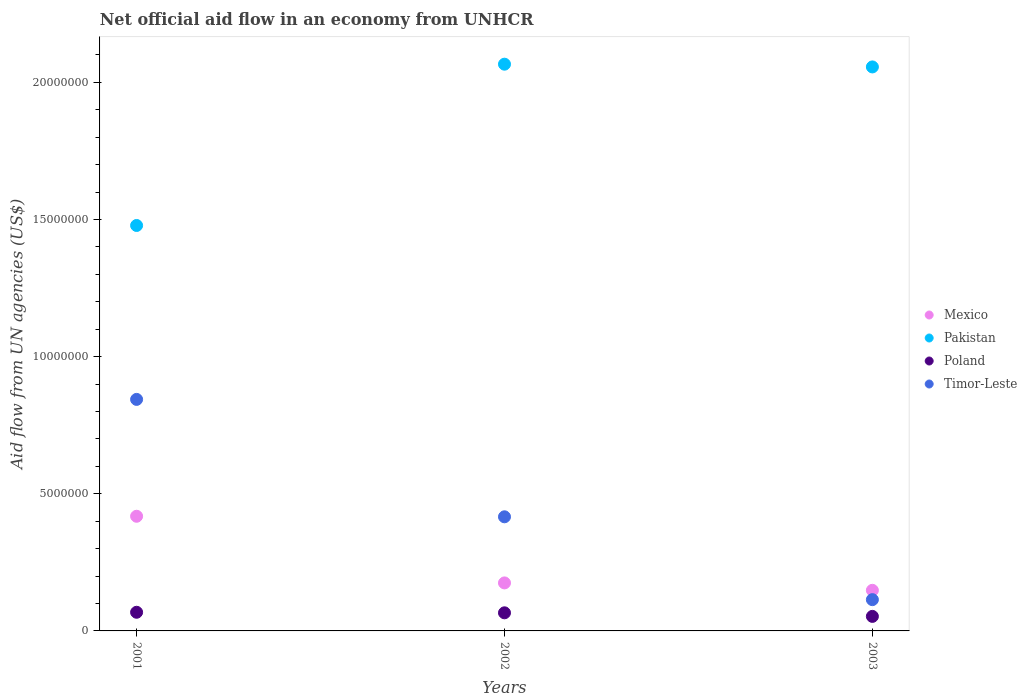Is the number of dotlines equal to the number of legend labels?
Provide a succinct answer. Yes. What is the net official aid flow in Poland in 2001?
Ensure brevity in your answer.  6.80e+05. Across all years, what is the maximum net official aid flow in Poland?
Make the answer very short. 6.80e+05. Across all years, what is the minimum net official aid flow in Mexico?
Offer a terse response. 1.48e+06. In which year was the net official aid flow in Timor-Leste maximum?
Make the answer very short. 2001. In which year was the net official aid flow in Timor-Leste minimum?
Your answer should be very brief. 2003. What is the total net official aid flow in Timor-Leste in the graph?
Ensure brevity in your answer.  1.37e+07. What is the difference between the net official aid flow in Pakistan in 2002 and that in 2003?
Provide a short and direct response. 1.00e+05. What is the difference between the net official aid flow in Pakistan in 2002 and the net official aid flow in Poland in 2003?
Keep it short and to the point. 2.01e+07. What is the average net official aid flow in Poland per year?
Keep it short and to the point. 6.23e+05. In the year 2002, what is the difference between the net official aid flow in Pakistan and net official aid flow in Poland?
Offer a very short reply. 2.00e+07. In how many years, is the net official aid flow in Pakistan greater than 2000000 US$?
Provide a succinct answer. 3. What is the ratio of the net official aid flow in Poland in 2001 to that in 2002?
Provide a short and direct response. 1.03. Is the net official aid flow in Poland in 2001 less than that in 2002?
Offer a terse response. No. What is the difference between the highest and the lowest net official aid flow in Mexico?
Keep it short and to the point. 2.70e+06. Is the sum of the net official aid flow in Mexico in 2002 and 2003 greater than the maximum net official aid flow in Poland across all years?
Make the answer very short. Yes. Is it the case that in every year, the sum of the net official aid flow in Mexico and net official aid flow in Poland  is greater than the net official aid flow in Pakistan?
Ensure brevity in your answer.  No. Does the net official aid flow in Pakistan monotonically increase over the years?
Provide a short and direct response. No. Does the graph contain grids?
Provide a succinct answer. No. Where does the legend appear in the graph?
Your answer should be very brief. Center right. How are the legend labels stacked?
Provide a succinct answer. Vertical. What is the title of the graph?
Offer a terse response. Net official aid flow in an economy from UNHCR. Does "Heavily indebted poor countries" appear as one of the legend labels in the graph?
Your answer should be compact. No. What is the label or title of the Y-axis?
Offer a terse response. Aid flow from UN agencies (US$). What is the Aid flow from UN agencies (US$) in Mexico in 2001?
Your response must be concise. 4.18e+06. What is the Aid flow from UN agencies (US$) in Pakistan in 2001?
Keep it short and to the point. 1.48e+07. What is the Aid flow from UN agencies (US$) in Poland in 2001?
Ensure brevity in your answer.  6.80e+05. What is the Aid flow from UN agencies (US$) in Timor-Leste in 2001?
Your answer should be compact. 8.44e+06. What is the Aid flow from UN agencies (US$) of Mexico in 2002?
Your answer should be compact. 1.75e+06. What is the Aid flow from UN agencies (US$) of Pakistan in 2002?
Your answer should be very brief. 2.07e+07. What is the Aid flow from UN agencies (US$) in Timor-Leste in 2002?
Offer a very short reply. 4.16e+06. What is the Aid flow from UN agencies (US$) in Mexico in 2003?
Your answer should be very brief. 1.48e+06. What is the Aid flow from UN agencies (US$) of Pakistan in 2003?
Ensure brevity in your answer.  2.06e+07. What is the Aid flow from UN agencies (US$) of Poland in 2003?
Offer a terse response. 5.30e+05. What is the Aid flow from UN agencies (US$) of Timor-Leste in 2003?
Your answer should be compact. 1.14e+06. Across all years, what is the maximum Aid flow from UN agencies (US$) in Mexico?
Make the answer very short. 4.18e+06. Across all years, what is the maximum Aid flow from UN agencies (US$) in Pakistan?
Offer a terse response. 2.07e+07. Across all years, what is the maximum Aid flow from UN agencies (US$) of Poland?
Offer a terse response. 6.80e+05. Across all years, what is the maximum Aid flow from UN agencies (US$) of Timor-Leste?
Provide a succinct answer. 8.44e+06. Across all years, what is the minimum Aid flow from UN agencies (US$) in Mexico?
Ensure brevity in your answer.  1.48e+06. Across all years, what is the minimum Aid flow from UN agencies (US$) of Pakistan?
Make the answer very short. 1.48e+07. Across all years, what is the minimum Aid flow from UN agencies (US$) of Poland?
Make the answer very short. 5.30e+05. Across all years, what is the minimum Aid flow from UN agencies (US$) of Timor-Leste?
Offer a very short reply. 1.14e+06. What is the total Aid flow from UN agencies (US$) in Mexico in the graph?
Offer a very short reply. 7.41e+06. What is the total Aid flow from UN agencies (US$) of Pakistan in the graph?
Your answer should be very brief. 5.60e+07. What is the total Aid flow from UN agencies (US$) of Poland in the graph?
Ensure brevity in your answer.  1.87e+06. What is the total Aid flow from UN agencies (US$) in Timor-Leste in the graph?
Give a very brief answer. 1.37e+07. What is the difference between the Aid flow from UN agencies (US$) of Mexico in 2001 and that in 2002?
Offer a terse response. 2.43e+06. What is the difference between the Aid flow from UN agencies (US$) in Pakistan in 2001 and that in 2002?
Offer a terse response. -5.88e+06. What is the difference between the Aid flow from UN agencies (US$) of Poland in 2001 and that in 2002?
Keep it short and to the point. 2.00e+04. What is the difference between the Aid flow from UN agencies (US$) in Timor-Leste in 2001 and that in 2002?
Make the answer very short. 4.28e+06. What is the difference between the Aid flow from UN agencies (US$) of Mexico in 2001 and that in 2003?
Provide a succinct answer. 2.70e+06. What is the difference between the Aid flow from UN agencies (US$) in Pakistan in 2001 and that in 2003?
Ensure brevity in your answer.  -5.78e+06. What is the difference between the Aid flow from UN agencies (US$) in Poland in 2001 and that in 2003?
Make the answer very short. 1.50e+05. What is the difference between the Aid flow from UN agencies (US$) of Timor-Leste in 2001 and that in 2003?
Provide a succinct answer. 7.30e+06. What is the difference between the Aid flow from UN agencies (US$) in Poland in 2002 and that in 2003?
Provide a short and direct response. 1.30e+05. What is the difference between the Aid flow from UN agencies (US$) of Timor-Leste in 2002 and that in 2003?
Make the answer very short. 3.02e+06. What is the difference between the Aid flow from UN agencies (US$) of Mexico in 2001 and the Aid flow from UN agencies (US$) of Pakistan in 2002?
Make the answer very short. -1.65e+07. What is the difference between the Aid flow from UN agencies (US$) in Mexico in 2001 and the Aid flow from UN agencies (US$) in Poland in 2002?
Offer a very short reply. 3.52e+06. What is the difference between the Aid flow from UN agencies (US$) of Mexico in 2001 and the Aid flow from UN agencies (US$) of Timor-Leste in 2002?
Your response must be concise. 2.00e+04. What is the difference between the Aid flow from UN agencies (US$) in Pakistan in 2001 and the Aid flow from UN agencies (US$) in Poland in 2002?
Provide a short and direct response. 1.41e+07. What is the difference between the Aid flow from UN agencies (US$) in Pakistan in 2001 and the Aid flow from UN agencies (US$) in Timor-Leste in 2002?
Provide a short and direct response. 1.06e+07. What is the difference between the Aid flow from UN agencies (US$) in Poland in 2001 and the Aid flow from UN agencies (US$) in Timor-Leste in 2002?
Your answer should be compact. -3.48e+06. What is the difference between the Aid flow from UN agencies (US$) in Mexico in 2001 and the Aid flow from UN agencies (US$) in Pakistan in 2003?
Your answer should be very brief. -1.64e+07. What is the difference between the Aid flow from UN agencies (US$) of Mexico in 2001 and the Aid flow from UN agencies (US$) of Poland in 2003?
Provide a short and direct response. 3.65e+06. What is the difference between the Aid flow from UN agencies (US$) in Mexico in 2001 and the Aid flow from UN agencies (US$) in Timor-Leste in 2003?
Your answer should be compact. 3.04e+06. What is the difference between the Aid flow from UN agencies (US$) in Pakistan in 2001 and the Aid flow from UN agencies (US$) in Poland in 2003?
Your answer should be compact. 1.42e+07. What is the difference between the Aid flow from UN agencies (US$) of Pakistan in 2001 and the Aid flow from UN agencies (US$) of Timor-Leste in 2003?
Ensure brevity in your answer.  1.36e+07. What is the difference between the Aid flow from UN agencies (US$) of Poland in 2001 and the Aid flow from UN agencies (US$) of Timor-Leste in 2003?
Ensure brevity in your answer.  -4.60e+05. What is the difference between the Aid flow from UN agencies (US$) of Mexico in 2002 and the Aid flow from UN agencies (US$) of Pakistan in 2003?
Your response must be concise. -1.88e+07. What is the difference between the Aid flow from UN agencies (US$) in Mexico in 2002 and the Aid flow from UN agencies (US$) in Poland in 2003?
Your answer should be compact. 1.22e+06. What is the difference between the Aid flow from UN agencies (US$) of Pakistan in 2002 and the Aid flow from UN agencies (US$) of Poland in 2003?
Your response must be concise. 2.01e+07. What is the difference between the Aid flow from UN agencies (US$) of Pakistan in 2002 and the Aid flow from UN agencies (US$) of Timor-Leste in 2003?
Provide a succinct answer. 1.95e+07. What is the difference between the Aid flow from UN agencies (US$) in Poland in 2002 and the Aid flow from UN agencies (US$) in Timor-Leste in 2003?
Ensure brevity in your answer.  -4.80e+05. What is the average Aid flow from UN agencies (US$) of Mexico per year?
Your answer should be compact. 2.47e+06. What is the average Aid flow from UN agencies (US$) of Pakistan per year?
Make the answer very short. 1.87e+07. What is the average Aid flow from UN agencies (US$) of Poland per year?
Provide a short and direct response. 6.23e+05. What is the average Aid flow from UN agencies (US$) of Timor-Leste per year?
Your answer should be very brief. 4.58e+06. In the year 2001, what is the difference between the Aid flow from UN agencies (US$) of Mexico and Aid flow from UN agencies (US$) of Pakistan?
Offer a very short reply. -1.06e+07. In the year 2001, what is the difference between the Aid flow from UN agencies (US$) of Mexico and Aid flow from UN agencies (US$) of Poland?
Give a very brief answer. 3.50e+06. In the year 2001, what is the difference between the Aid flow from UN agencies (US$) in Mexico and Aid flow from UN agencies (US$) in Timor-Leste?
Your response must be concise. -4.26e+06. In the year 2001, what is the difference between the Aid flow from UN agencies (US$) in Pakistan and Aid flow from UN agencies (US$) in Poland?
Provide a short and direct response. 1.41e+07. In the year 2001, what is the difference between the Aid flow from UN agencies (US$) of Pakistan and Aid flow from UN agencies (US$) of Timor-Leste?
Your answer should be compact. 6.34e+06. In the year 2001, what is the difference between the Aid flow from UN agencies (US$) in Poland and Aid flow from UN agencies (US$) in Timor-Leste?
Provide a succinct answer. -7.76e+06. In the year 2002, what is the difference between the Aid flow from UN agencies (US$) in Mexico and Aid flow from UN agencies (US$) in Pakistan?
Your response must be concise. -1.89e+07. In the year 2002, what is the difference between the Aid flow from UN agencies (US$) of Mexico and Aid flow from UN agencies (US$) of Poland?
Your answer should be very brief. 1.09e+06. In the year 2002, what is the difference between the Aid flow from UN agencies (US$) in Mexico and Aid flow from UN agencies (US$) in Timor-Leste?
Your response must be concise. -2.41e+06. In the year 2002, what is the difference between the Aid flow from UN agencies (US$) in Pakistan and Aid flow from UN agencies (US$) in Timor-Leste?
Offer a very short reply. 1.65e+07. In the year 2002, what is the difference between the Aid flow from UN agencies (US$) of Poland and Aid flow from UN agencies (US$) of Timor-Leste?
Keep it short and to the point. -3.50e+06. In the year 2003, what is the difference between the Aid flow from UN agencies (US$) in Mexico and Aid flow from UN agencies (US$) in Pakistan?
Keep it short and to the point. -1.91e+07. In the year 2003, what is the difference between the Aid flow from UN agencies (US$) of Mexico and Aid flow from UN agencies (US$) of Poland?
Your response must be concise. 9.50e+05. In the year 2003, what is the difference between the Aid flow from UN agencies (US$) in Pakistan and Aid flow from UN agencies (US$) in Poland?
Make the answer very short. 2.00e+07. In the year 2003, what is the difference between the Aid flow from UN agencies (US$) of Pakistan and Aid flow from UN agencies (US$) of Timor-Leste?
Your response must be concise. 1.94e+07. In the year 2003, what is the difference between the Aid flow from UN agencies (US$) in Poland and Aid flow from UN agencies (US$) in Timor-Leste?
Provide a short and direct response. -6.10e+05. What is the ratio of the Aid flow from UN agencies (US$) of Mexico in 2001 to that in 2002?
Offer a terse response. 2.39. What is the ratio of the Aid flow from UN agencies (US$) in Pakistan in 2001 to that in 2002?
Your answer should be very brief. 0.72. What is the ratio of the Aid flow from UN agencies (US$) of Poland in 2001 to that in 2002?
Your response must be concise. 1.03. What is the ratio of the Aid flow from UN agencies (US$) of Timor-Leste in 2001 to that in 2002?
Provide a succinct answer. 2.03. What is the ratio of the Aid flow from UN agencies (US$) of Mexico in 2001 to that in 2003?
Make the answer very short. 2.82. What is the ratio of the Aid flow from UN agencies (US$) in Pakistan in 2001 to that in 2003?
Offer a terse response. 0.72. What is the ratio of the Aid flow from UN agencies (US$) in Poland in 2001 to that in 2003?
Keep it short and to the point. 1.28. What is the ratio of the Aid flow from UN agencies (US$) of Timor-Leste in 2001 to that in 2003?
Offer a terse response. 7.4. What is the ratio of the Aid flow from UN agencies (US$) in Mexico in 2002 to that in 2003?
Keep it short and to the point. 1.18. What is the ratio of the Aid flow from UN agencies (US$) in Poland in 2002 to that in 2003?
Give a very brief answer. 1.25. What is the ratio of the Aid flow from UN agencies (US$) in Timor-Leste in 2002 to that in 2003?
Keep it short and to the point. 3.65. What is the difference between the highest and the second highest Aid flow from UN agencies (US$) in Mexico?
Your answer should be compact. 2.43e+06. What is the difference between the highest and the second highest Aid flow from UN agencies (US$) of Pakistan?
Provide a succinct answer. 1.00e+05. What is the difference between the highest and the second highest Aid flow from UN agencies (US$) in Poland?
Your response must be concise. 2.00e+04. What is the difference between the highest and the second highest Aid flow from UN agencies (US$) in Timor-Leste?
Give a very brief answer. 4.28e+06. What is the difference between the highest and the lowest Aid flow from UN agencies (US$) in Mexico?
Your answer should be compact. 2.70e+06. What is the difference between the highest and the lowest Aid flow from UN agencies (US$) of Pakistan?
Keep it short and to the point. 5.88e+06. What is the difference between the highest and the lowest Aid flow from UN agencies (US$) of Poland?
Offer a terse response. 1.50e+05. What is the difference between the highest and the lowest Aid flow from UN agencies (US$) of Timor-Leste?
Provide a short and direct response. 7.30e+06. 